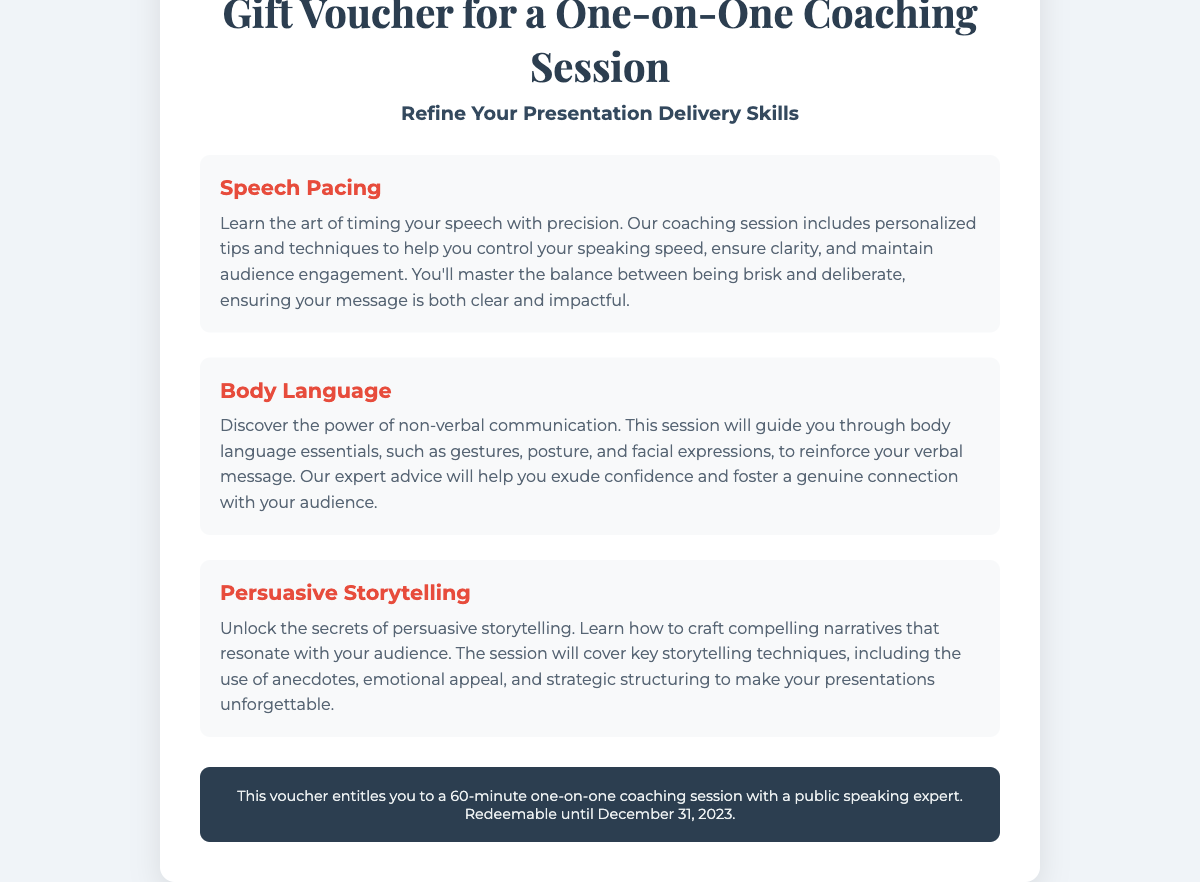What is the title of the gift voucher? The title of the gift voucher is prominently displayed at the top of the document.
Answer: Gift Voucher for a One-on-One Coaching Session What are the three main components of the coaching session? The document lists the key areas covered in the coaching session, which can be found under section headings.
Answer: Speech Pacing, Body Language, Persuasive Storytelling How long is the coaching session? The duration of the coaching session is mentioned in the footer of the document.
Answer: 60 minutes What is the expiry date of the voucher? The document specifies the date until which the voucher can be redeemed.
Answer: December 31, 2023 What type of communication does the Body Language section focus on? The section discusses non-verbal communication's impact on delivery.
Answer: Non-verbal communication Which storytelling aspect is emphasized in the coaching session? The document highlights the importance of crafting compelling narratives.
Answer: Persuasive storytelling 